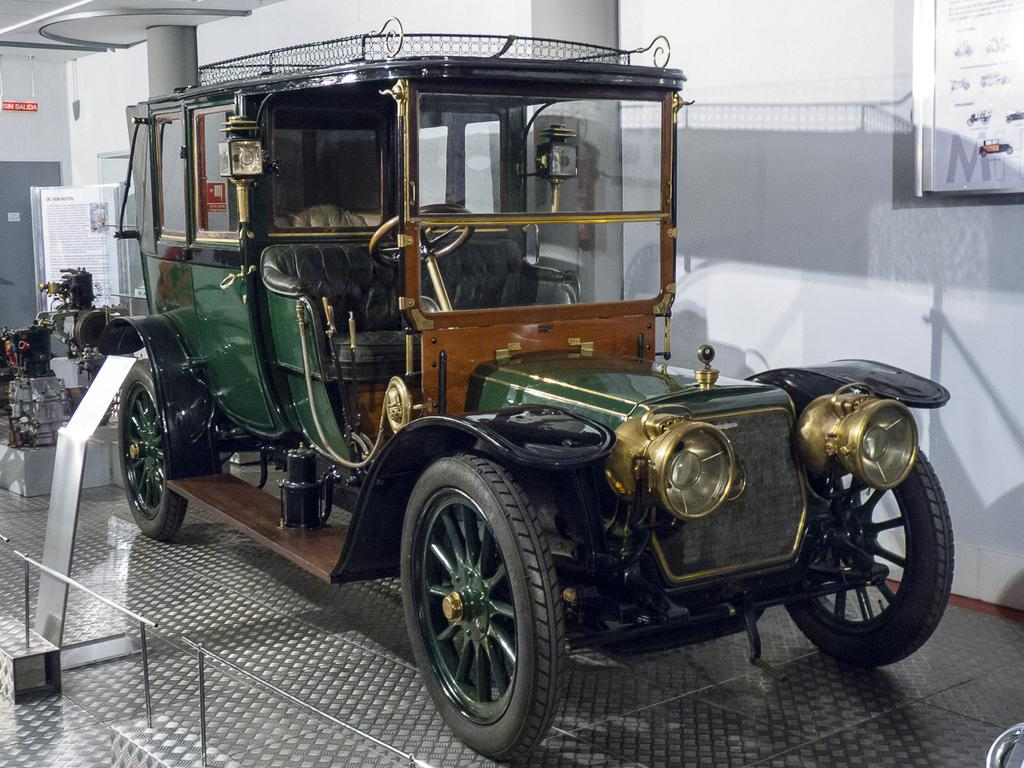What is the main subject of the image? There is a vehicle in the image. Where is the vehicle located? The vehicle is on the floor. What can be seen in the background of the image? There is a wall and two pillars in the background of the image. What is present on the left side of the image? There is an equipment on the left side of the image. How many knees are visible in the image? There are no knees visible in the image. What type of button can be seen on the vehicle? There is no button present on the vehicle in the image. 